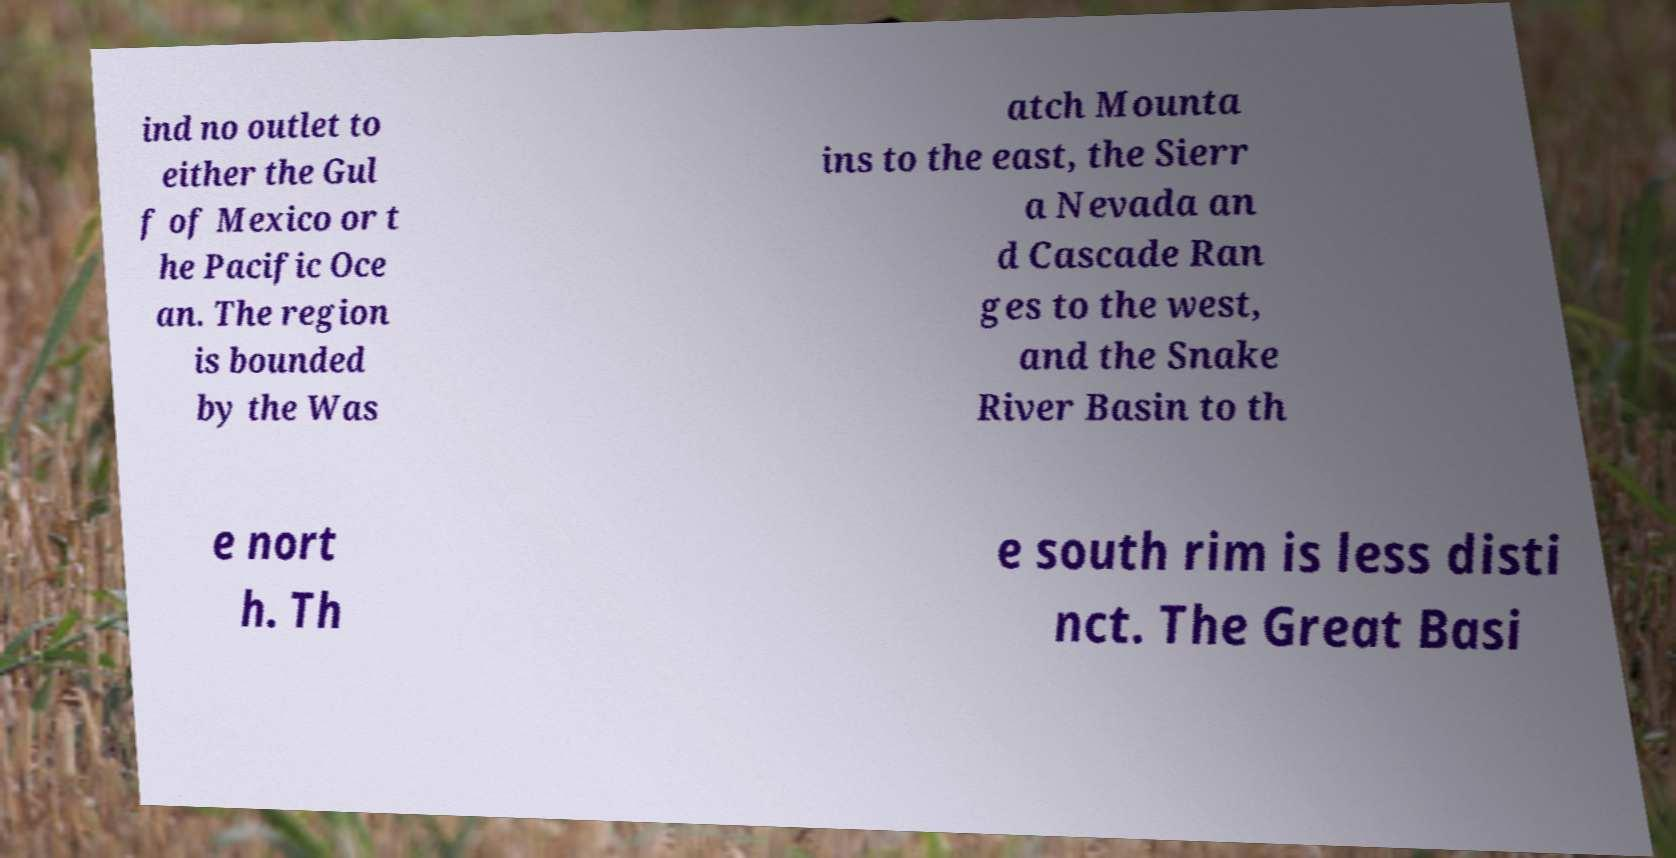What messages or text are displayed in this image? I need them in a readable, typed format. ind no outlet to either the Gul f of Mexico or t he Pacific Oce an. The region is bounded by the Was atch Mounta ins to the east, the Sierr a Nevada an d Cascade Ran ges to the west, and the Snake River Basin to th e nort h. Th e south rim is less disti nct. The Great Basi 